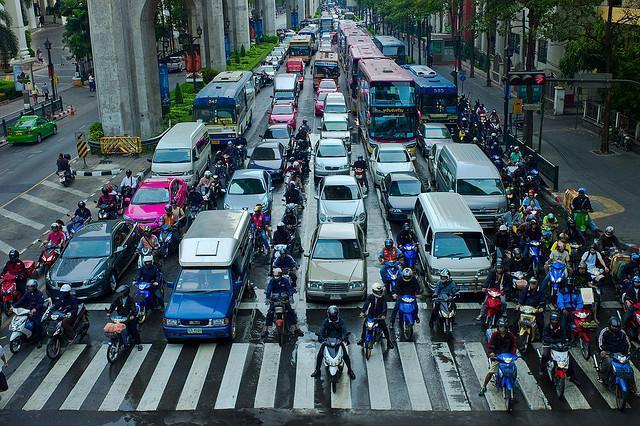How many buses are in the photo?
Give a very brief answer. 2. How many cars are visible?
Give a very brief answer. 5. How many trucks can be seen?
Give a very brief answer. 3. 